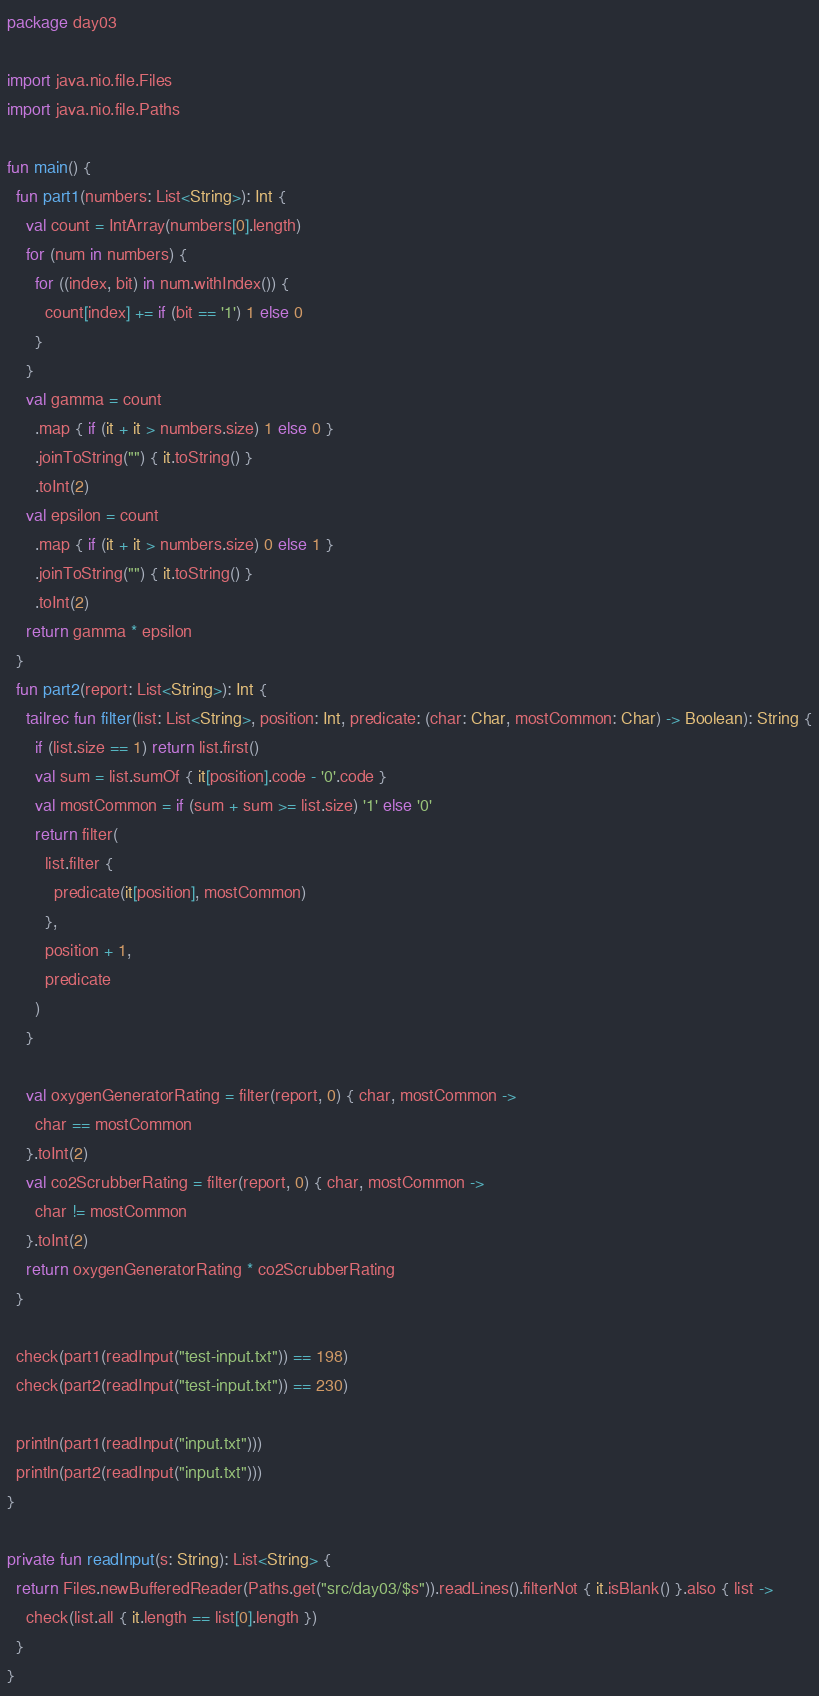Convert code to text. <code><loc_0><loc_0><loc_500><loc_500><_Kotlin_>package day03

import java.nio.file.Files
import java.nio.file.Paths

fun main() {
  fun part1(numbers: List<String>): Int {
    val count = IntArray(numbers[0].length)
    for (num in numbers) {
      for ((index, bit) in num.withIndex()) {
        count[index] += if (bit == '1') 1 else 0
      }
    }
    val gamma = count
      .map { if (it + it > numbers.size) 1 else 0 }
      .joinToString("") { it.toString() }
      .toInt(2)
    val epsilon = count
      .map { if (it + it > numbers.size) 0 else 1 }
      .joinToString("") { it.toString() }
      .toInt(2)
    return gamma * epsilon
  }
  fun part2(report: List<String>): Int {
    tailrec fun filter(list: List<String>, position: Int, predicate: (char: Char, mostCommon: Char) -> Boolean): String {
      if (list.size == 1) return list.first()
      val sum = list.sumOf { it[position].code - '0'.code }
      val mostCommon = if (sum + sum >= list.size) '1' else '0'
      return filter(
        list.filter {
          predicate(it[position], mostCommon)
        },
        position + 1,
        predicate
      )
    }

    val oxygenGeneratorRating = filter(report, 0) { char, mostCommon ->
      char == mostCommon
    }.toInt(2)
    val co2ScrubberRating = filter(report, 0) { char, mostCommon ->
      char != mostCommon
    }.toInt(2)
    return oxygenGeneratorRating * co2ScrubberRating
  }

  check(part1(readInput("test-input.txt")) == 198)
  check(part2(readInput("test-input.txt")) == 230)

  println(part1(readInput("input.txt")))
  println(part2(readInput("input.txt")))
}

private fun readInput(s: String): List<String> {
  return Files.newBufferedReader(Paths.get("src/day03/$s")).readLines().filterNot { it.isBlank() }.also { list ->
    check(list.all { it.length == list[0].length })
  }
}</code> 